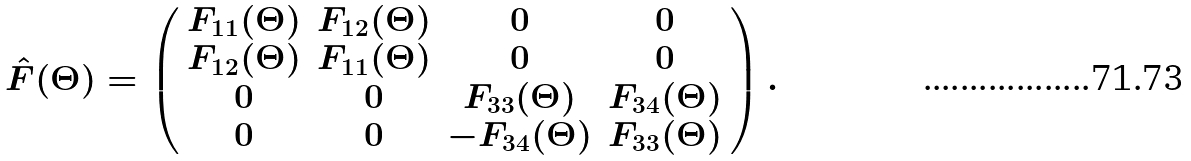Convert formula to latex. <formula><loc_0><loc_0><loc_500><loc_500>\hat { F } ( \Theta ) = \left ( \begin{array} { c c c c } F _ { 1 1 } ( \Theta ) & F _ { 1 2 } ( \Theta ) & 0 & 0 \\ F _ { 1 2 } ( \Theta ) & F _ { 1 1 } ( \Theta ) & 0 & 0 \\ 0 & 0 & F _ { 3 3 } ( \Theta ) & F _ { 3 4 } ( \Theta ) \\ 0 & 0 & - F _ { 3 4 } ( \Theta ) & F _ { 3 3 } ( \Theta ) \end{array} \right ) .</formula> 